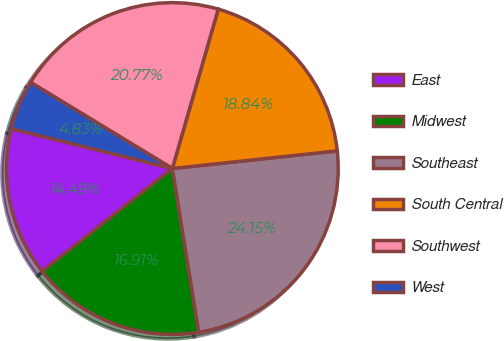Convert chart. <chart><loc_0><loc_0><loc_500><loc_500><pie_chart><fcel>East<fcel>Midwest<fcel>Southeast<fcel>South Central<fcel>Southwest<fcel>West<nl><fcel>14.49%<fcel>16.91%<fcel>24.15%<fcel>18.84%<fcel>20.77%<fcel>4.83%<nl></chart> 